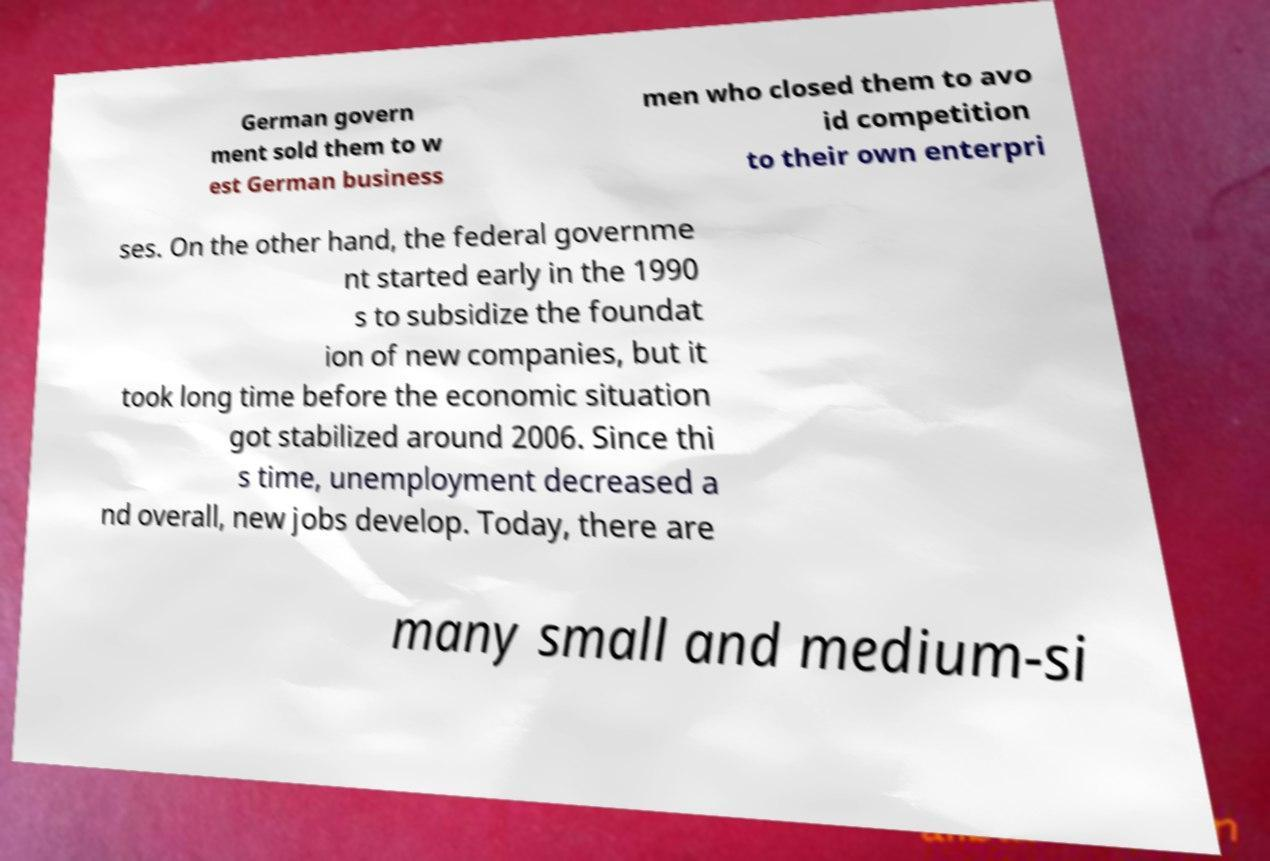Please identify and transcribe the text found in this image. German govern ment sold them to w est German business men who closed them to avo id competition to their own enterpri ses. On the other hand, the federal governme nt started early in the 1990 s to subsidize the foundat ion of new companies, but it took long time before the economic situation got stabilized around 2006. Since thi s time, unemployment decreased a nd overall, new jobs develop. Today, there are many small and medium-si 